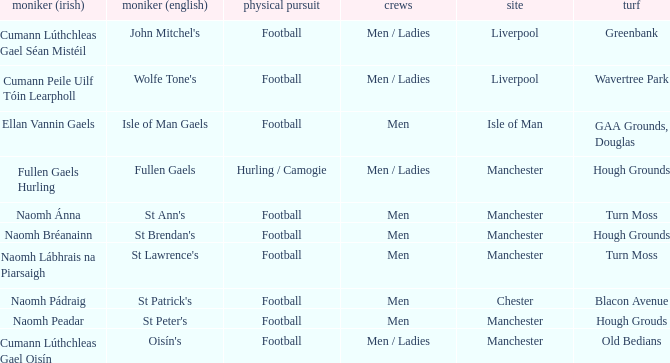What is the Location of the Old Bedians Pitch? Manchester. 